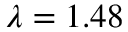Convert formula to latex. <formula><loc_0><loc_0><loc_500><loc_500>\lambda = 1 . 4 8</formula> 